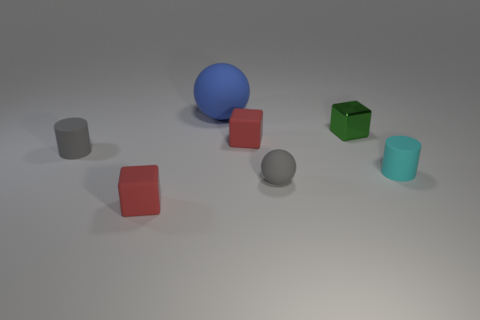Is there any other thing that has the same material as the small green cube?
Keep it short and to the point. No. There is a small green thing; does it have the same shape as the small rubber object to the right of the small matte ball?
Provide a short and direct response. No. How many other things are there of the same size as the metal object?
Offer a very short reply. 5. How big is the thing that is in front of the gray rubber ball?
Your answer should be very brief. Small. How many gray things have the same material as the big blue ball?
Provide a short and direct response. 2. Does the red matte object that is to the right of the big blue object have the same shape as the metallic thing?
Your response must be concise. Yes. The small gray rubber object on the right side of the big sphere has what shape?
Provide a succinct answer. Sphere. What is the size of the matte cylinder that is the same color as the tiny matte ball?
Your answer should be very brief. Small. What material is the large sphere?
Your answer should be compact. Rubber. What is the color of the metallic cube that is the same size as the cyan matte thing?
Your answer should be compact. Green. 